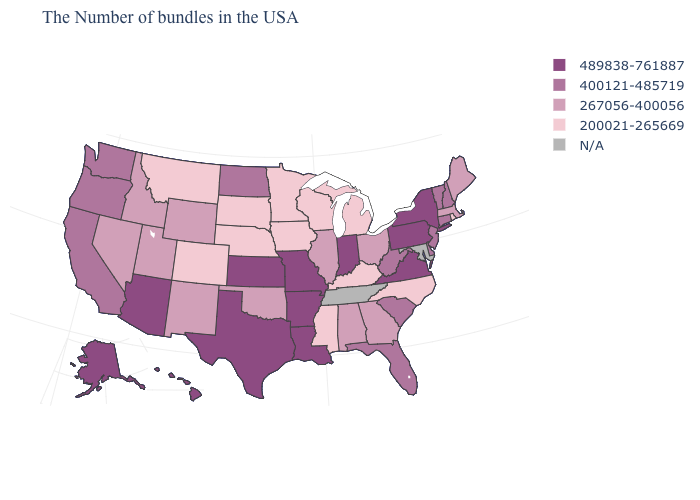Which states have the lowest value in the USA?
Concise answer only. Rhode Island, North Carolina, Michigan, Kentucky, Wisconsin, Mississippi, Minnesota, Iowa, Nebraska, South Dakota, Colorado, Montana. Is the legend a continuous bar?
Concise answer only. No. Which states have the lowest value in the USA?
Concise answer only. Rhode Island, North Carolina, Michigan, Kentucky, Wisconsin, Mississippi, Minnesota, Iowa, Nebraska, South Dakota, Colorado, Montana. Name the states that have a value in the range 200021-265669?
Give a very brief answer. Rhode Island, North Carolina, Michigan, Kentucky, Wisconsin, Mississippi, Minnesota, Iowa, Nebraska, South Dakota, Colorado, Montana. Does New Jersey have the highest value in the USA?
Answer briefly. No. Does Oklahoma have the lowest value in the South?
Give a very brief answer. No. What is the highest value in the USA?
Quick response, please. 489838-761887. What is the lowest value in the Northeast?
Give a very brief answer. 200021-265669. Name the states that have a value in the range 200021-265669?
Answer briefly. Rhode Island, North Carolina, Michigan, Kentucky, Wisconsin, Mississippi, Minnesota, Iowa, Nebraska, South Dakota, Colorado, Montana. Name the states that have a value in the range N/A?
Write a very short answer. Maryland, Tennessee. What is the value of Oregon?
Answer briefly. 400121-485719. What is the highest value in the USA?
Concise answer only. 489838-761887. What is the value of Virginia?
Concise answer only. 489838-761887. 